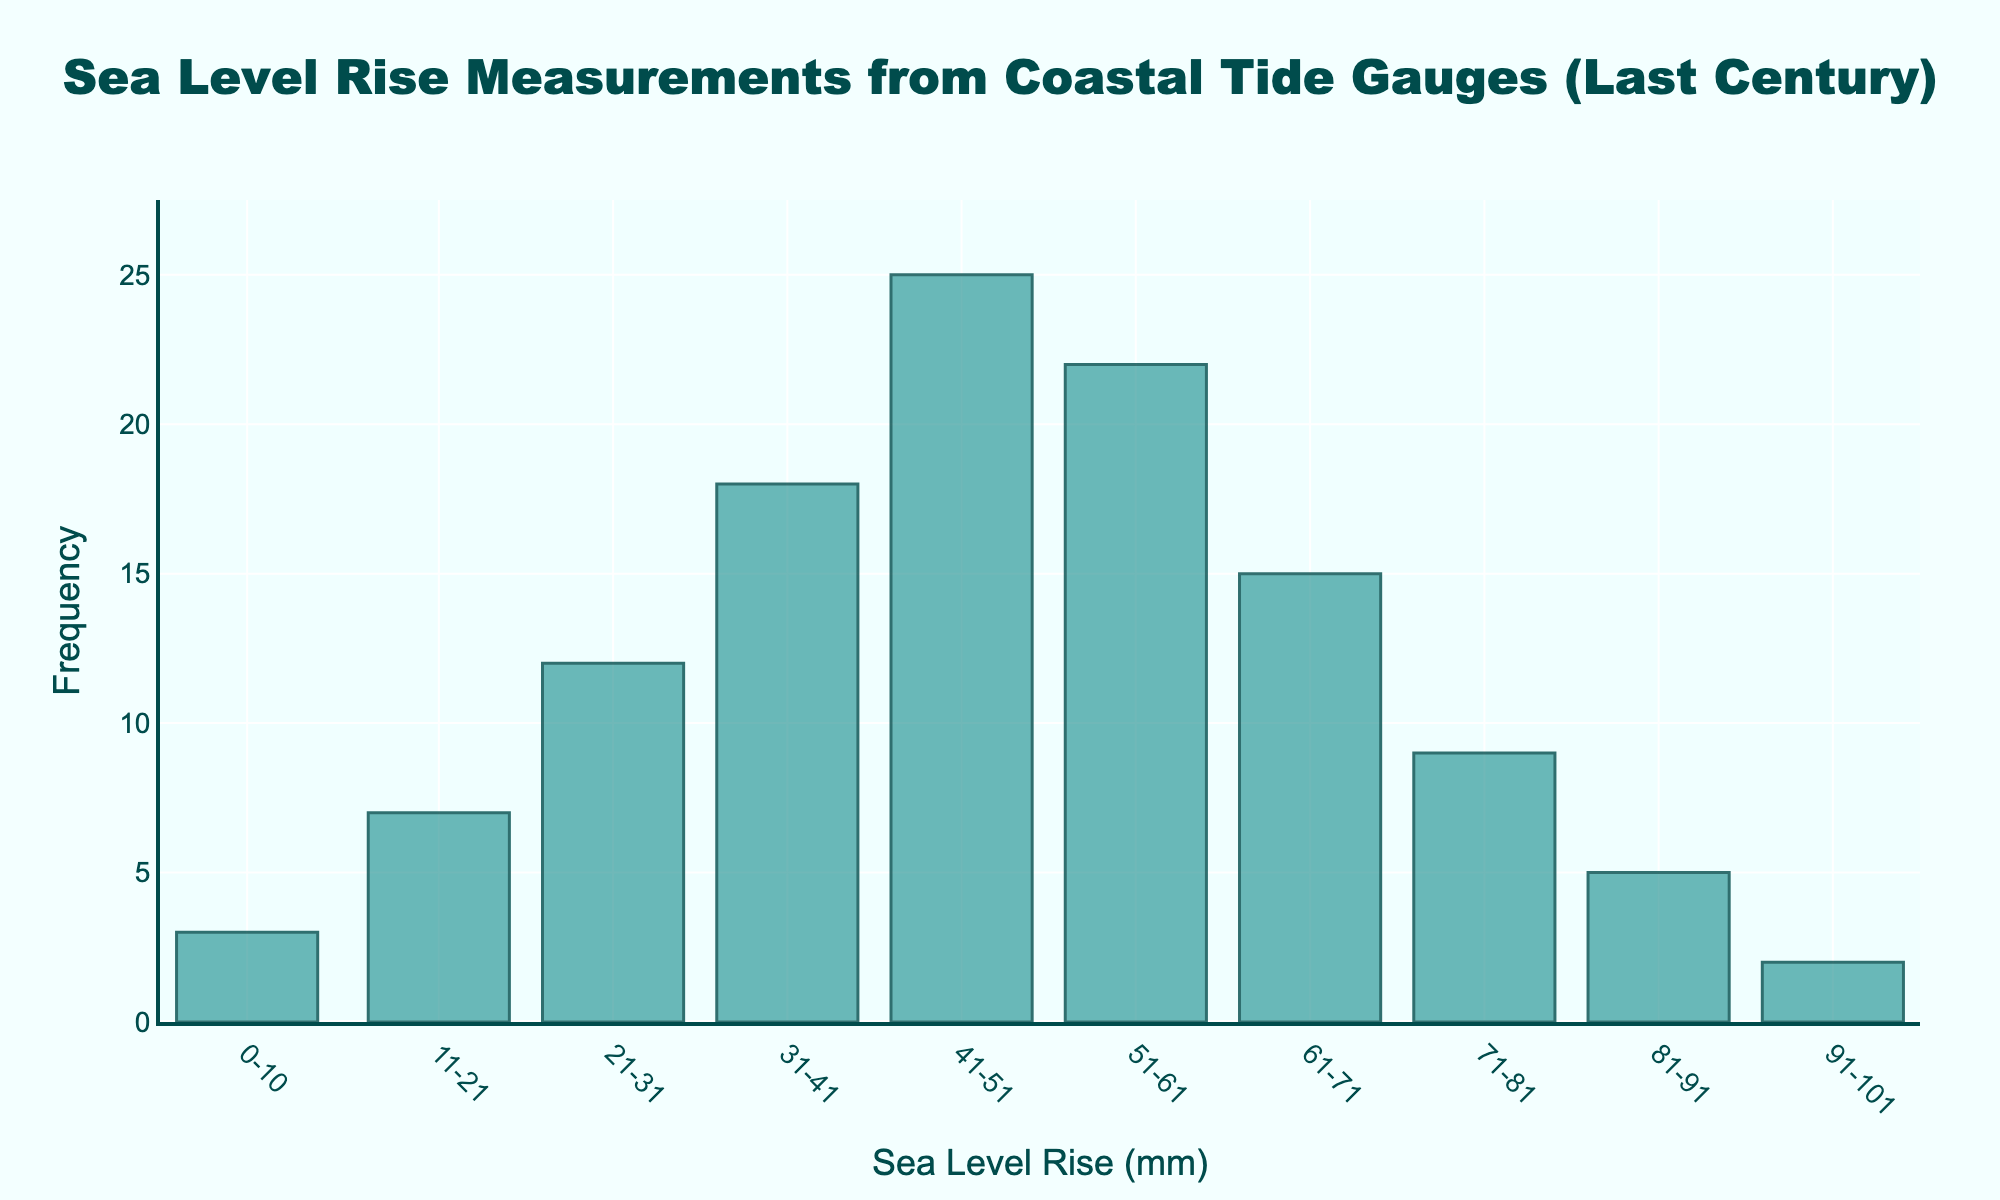What's the title of the figure? The title is located at the top of the figure, and it reads "Sea Level Rise Measurements from Coastal Tide Gauges (Last Century)".
Answer: Sea Level Rise Measurements from Coastal Tide Gauges (Last Century) What is the most frequent range of sea level rise (in mm)? The highest bar in the figure corresponds to the range 41-50 mm, indicating that this is the most frequent range.
Answer: 41-50 mm Which range of sea level rise has the least measurements? The smallest bar in the figure corresponds to the range 91-100 mm, indicating that this is the least frequent range.
Answer: 91-100 mm How many measurements fall within the 51-60 mm range? The bar corresponding to 51-60 mm reaches up to the frequency of 22.
Answer: 22 What is the combined frequency of measurements in the 31-40 mm and 41-50 mm ranges? The frequency for 31-40 mm is 18, and for 41-50 mm is 25. Adding them together (18 + 25) gives 43.
Answer: 43 Is the frequency of the 61-70 mm range greater or smaller than the 71-80 mm range? The frequency of the 61-70 mm range is 15, which is greater than the 71-80 mm range, which is 9.
Answer: Greater By how much does the frequency of the 51-60 mm range differ from that of the 41-50 mm range? The frequency of 51-60 mm is 22, and for 41-50 mm it is 25. The difference is 25 - 22 = 3.
Answer: 3 What is the overall trend in frequency as the sea level rise increases from 0-10 mm to 41-50 mm? The frequency generally increases, with the number of measurements rising progressively from 3 to 25 as the sea level range increases from 0-10 mm to 41-50 mm.
Answer: Increases Does the frequency show a peak within a specific range before starting to decline? Yes, the frequency peaks at 41-50 mm (25 measurements) before it starts to decline in the higher ranges.
Answer: Yes Can you identify a range where the frequency suddenly drops compared to its adjacent range? The frequency drops from 22 for 51-60 mm to 15 for 61-70 mm, a difference of 7.
Answer: 61-70 mm 